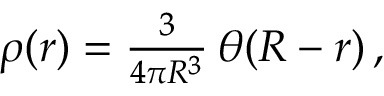Convert formula to latex. <formula><loc_0><loc_0><loc_500><loc_500>\begin{array} { r } { \rho ( r ) = \frac { 3 } { 4 \pi R ^ { 3 } } \, \theta ( R - r ) \, , } \end{array}</formula> 